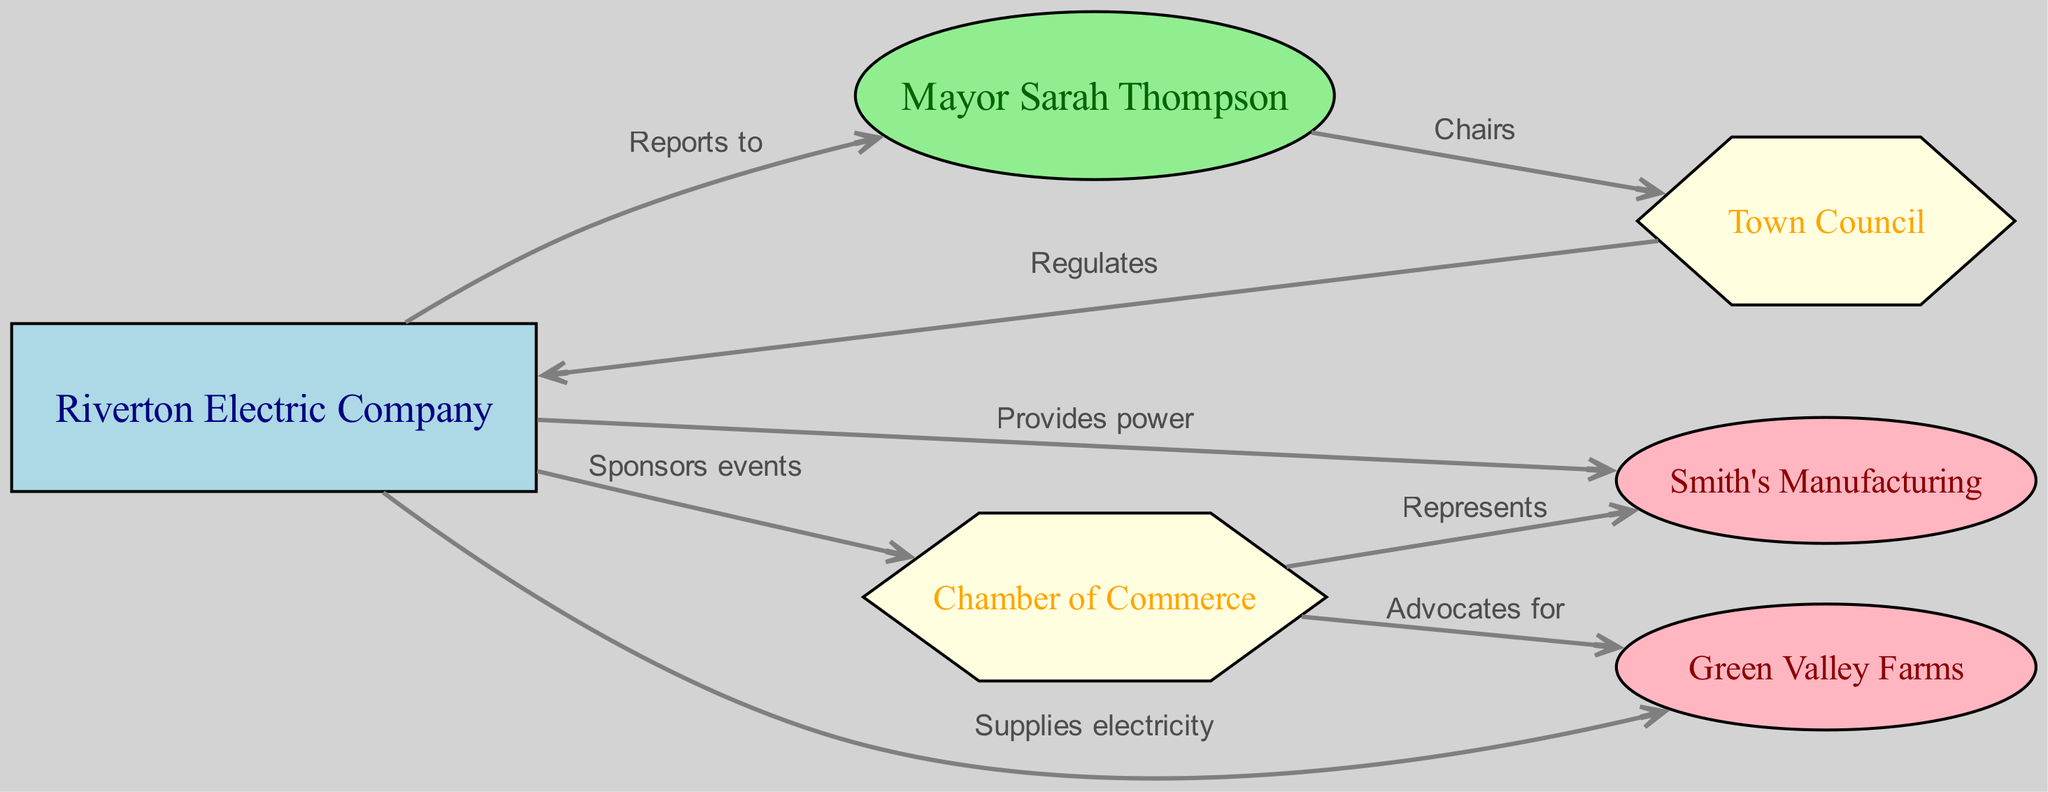What is the total number of nodes in the diagram? The diagram contains a list of nodes representing various entities including businesses, the electric company, town officials, and the Chamber of Commerce. By counting all listed entities in the provided data, we find there are six nodes in total.
Answer: 6 Which business receives power from the Riverton Electric Company? According to the edge labeled "Provides power," the direct relationship identified indicates that Smith's Manufacturing receives power from the Riverton Electric Company.
Answer: Smith's Manufacturing Who chairs the Town Council? The diagram shows a connection where Mayor Sarah Thompson is labeled as "Chairs" in relation to the Town Council. This relationship means she holds the position that oversees the Town Council's activities.
Answer: Mayor Sarah Thompson How many edges connect the Riverton Electric Company to other entities? By reviewing the edges linked to the Riverton Electric Company, we see it connects to Mayor Sarah Thompson, the Chamber of Commerce, Smith's Manufacturing, and Green Valley Farms, totaling four connections.
Answer: 4 What role does the Chamber of Commerce play in relation to Green Valley Farms? The edge indicates that the Chamber of Commerce "Advocates for" Green Valley Farms, establishing a supportive relationship where the Chamber represents the interests of Green Valley Farms within the town scope.
Answer: Advocates for Which entity regulates the Riverton Electric Company? The directed edge labeled "Regulates" leads from the Town Council to the Riverton Electric Company, indicating that the Town Council has the authority to oversee and manage the operations of the electric company.
Answer: Town Council What relationship is represented between the Chamber of Commerce and Smith's Manufacturing? The diagram displays a connection where the Chamber of Commerce is labeled "Represents" in relation to Smith's Manufacturing, which illustrates that the Chamber acts on behalf of this business in community or economic matters.
Answer: Represents Who sponsors events according to the diagram? The Riverton Electric Company is indicated to "Sponsors events" connecting it to the Chamber of Commerce, establishing its role in supporting local events.
Answer: Riverton Electric Company 